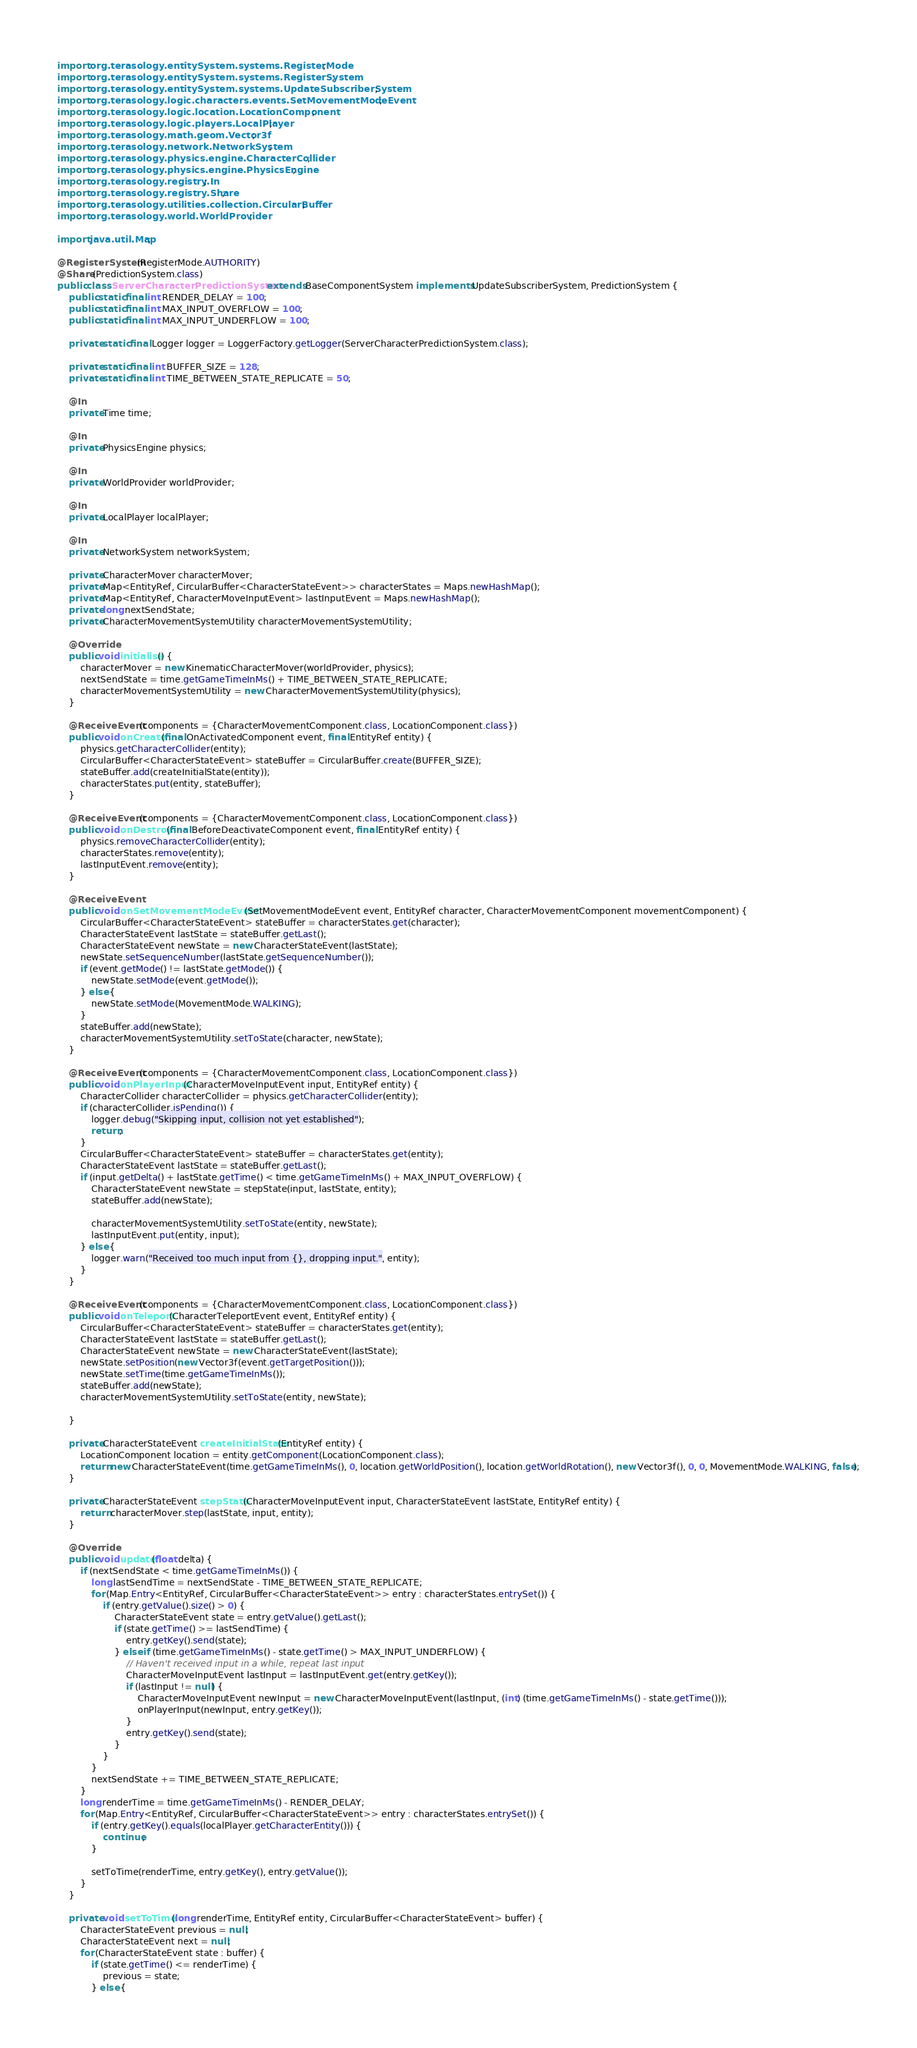Convert code to text. <code><loc_0><loc_0><loc_500><loc_500><_Java_>import org.terasology.entitySystem.systems.RegisterMode;
import org.terasology.entitySystem.systems.RegisterSystem;
import org.terasology.entitySystem.systems.UpdateSubscriberSystem;
import org.terasology.logic.characters.events.SetMovementModeEvent;
import org.terasology.logic.location.LocationComponent;
import org.terasology.logic.players.LocalPlayer;
import org.terasology.math.geom.Vector3f;
import org.terasology.network.NetworkSystem;
import org.terasology.physics.engine.CharacterCollider;
import org.terasology.physics.engine.PhysicsEngine;
import org.terasology.registry.In;
import org.terasology.registry.Share;
import org.terasology.utilities.collection.CircularBuffer;
import org.terasology.world.WorldProvider;

import java.util.Map;

@RegisterSystem(RegisterMode.AUTHORITY)
@Share(PredictionSystem.class)
public class ServerCharacterPredictionSystem extends BaseComponentSystem implements UpdateSubscriberSystem, PredictionSystem {
    public static final int RENDER_DELAY = 100;
    public static final int MAX_INPUT_OVERFLOW = 100;
    public static final int MAX_INPUT_UNDERFLOW = 100;

    private static final Logger logger = LoggerFactory.getLogger(ServerCharacterPredictionSystem.class);

    private static final int BUFFER_SIZE = 128;
    private static final int TIME_BETWEEN_STATE_REPLICATE = 50;

    @In
    private Time time;

    @In
    private PhysicsEngine physics;

    @In
    private WorldProvider worldProvider;

    @In
    private LocalPlayer localPlayer;

    @In
    private NetworkSystem networkSystem;

    private CharacterMover characterMover;
    private Map<EntityRef, CircularBuffer<CharacterStateEvent>> characterStates = Maps.newHashMap();
    private Map<EntityRef, CharacterMoveInputEvent> lastInputEvent = Maps.newHashMap();
    private long nextSendState;
    private CharacterMovementSystemUtility characterMovementSystemUtility;

    @Override
    public void initialise() {
        characterMover = new KinematicCharacterMover(worldProvider, physics);
        nextSendState = time.getGameTimeInMs() + TIME_BETWEEN_STATE_REPLICATE;
        characterMovementSystemUtility = new CharacterMovementSystemUtility(physics);
    }

    @ReceiveEvent(components = {CharacterMovementComponent.class, LocationComponent.class})
    public void onCreate(final OnActivatedComponent event, final EntityRef entity) {
        physics.getCharacterCollider(entity);
        CircularBuffer<CharacterStateEvent> stateBuffer = CircularBuffer.create(BUFFER_SIZE);
        stateBuffer.add(createInitialState(entity));
        characterStates.put(entity, stateBuffer);
    }

    @ReceiveEvent(components = {CharacterMovementComponent.class, LocationComponent.class})
    public void onDestroy(final BeforeDeactivateComponent event, final EntityRef entity) {
        physics.removeCharacterCollider(entity);
        characterStates.remove(entity);
        lastInputEvent.remove(entity);
    }

    @ReceiveEvent
    public void onSetMovementModeEvent(SetMovementModeEvent event, EntityRef character, CharacterMovementComponent movementComponent) {
        CircularBuffer<CharacterStateEvent> stateBuffer = characterStates.get(character);
        CharacterStateEvent lastState = stateBuffer.getLast();
        CharacterStateEvent newState = new CharacterStateEvent(lastState);
        newState.setSequenceNumber(lastState.getSequenceNumber());
        if (event.getMode() != lastState.getMode()) {
            newState.setMode(event.getMode());
        } else {
            newState.setMode(MovementMode.WALKING);
        }
        stateBuffer.add(newState);
        characterMovementSystemUtility.setToState(character, newState);
    }

    @ReceiveEvent(components = {CharacterMovementComponent.class, LocationComponent.class})
    public void onPlayerInput(CharacterMoveInputEvent input, EntityRef entity) {
        CharacterCollider characterCollider = physics.getCharacterCollider(entity);
        if (characterCollider.isPending()) {
            logger.debug("Skipping input, collision not yet established");
            return;
        }
        CircularBuffer<CharacterStateEvent> stateBuffer = characterStates.get(entity);
        CharacterStateEvent lastState = stateBuffer.getLast();
        if (input.getDelta() + lastState.getTime() < time.getGameTimeInMs() + MAX_INPUT_OVERFLOW) {
            CharacterStateEvent newState = stepState(input, lastState, entity);
            stateBuffer.add(newState);

            characterMovementSystemUtility.setToState(entity, newState);
            lastInputEvent.put(entity, input);
        } else {
            logger.warn("Received too much input from {}, dropping input.", entity);
        }
    }

    @ReceiveEvent(components = {CharacterMovementComponent.class, LocationComponent.class})
    public void onTeleport(CharacterTeleportEvent event, EntityRef entity) {
        CircularBuffer<CharacterStateEvent> stateBuffer = characterStates.get(entity);
        CharacterStateEvent lastState = stateBuffer.getLast();
        CharacterStateEvent newState = new CharacterStateEvent(lastState);
        newState.setPosition(new Vector3f(event.getTargetPosition()));
        newState.setTime(time.getGameTimeInMs());
        stateBuffer.add(newState);
        characterMovementSystemUtility.setToState(entity, newState);

    }

    private CharacterStateEvent createInitialState(EntityRef entity) {
        LocationComponent location = entity.getComponent(LocationComponent.class);
        return new CharacterStateEvent(time.getGameTimeInMs(), 0, location.getWorldPosition(), location.getWorldRotation(), new Vector3f(), 0, 0, MovementMode.WALKING, false);
    }

    private CharacterStateEvent stepState(CharacterMoveInputEvent input, CharacterStateEvent lastState, EntityRef entity) {
        return characterMover.step(lastState, input, entity);
    }

    @Override
    public void update(float delta) {
        if (nextSendState < time.getGameTimeInMs()) {
            long lastSendTime = nextSendState - TIME_BETWEEN_STATE_REPLICATE;
            for (Map.Entry<EntityRef, CircularBuffer<CharacterStateEvent>> entry : characterStates.entrySet()) {
                if (entry.getValue().size() > 0) {
                    CharacterStateEvent state = entry.getValue().getLast();
                    if (state.getTime() >= lastSendTime) {
                        entry.getKey().send(state);
                    } else if (time.getGameTimeInMs() - state.getTime() > MAX_INPUT_UNDERFLOW) {
                        // Haven't received input in a while, repeat last input
                        CharacterMoveInputEvent lastInput = lastInputEvent.get(entry.getKey());
                        if (lastInput != null) {
                            CharacterMoveInputEvent newInput = new CharacterMoveInputEvent(lastInput, (int) (time.getGameTimeInMs() - state.getTime()));
                            onPlayerInput(newInput, entry.getKey());
                        }
                        entry.getKey().send(state);
                    }
                }
            }
            nextSendState += TIME_BETWEEN_STATE_REPLICATE;
        }
        long renderTime = time.getGameTimeInMs() - RENDER_DELAY;
        for (Map.Entry<EntityRef, CircularBuffer<CharacterStateEvent>> entry : characterStates.entrySet()) {
            if (entry.getKey().equals(localPlayer.getCharacterEntity())) {
                continue;
            }

            setToTime(renderTime, entry.getKey(), entry.getValue());
        }
    }

    private void setToTime(long renderTime, EntityRef entity, CircularBuffer<CharacterStateEvent> buffer) {
        CharacterStateEvent previous = null;
        CharacterStateEvent next = null;
        for (CharacterStateEvent state : buffer) {
            if (state.getTime() <= renderTime) {
                previous = state;
            } else {</code> 